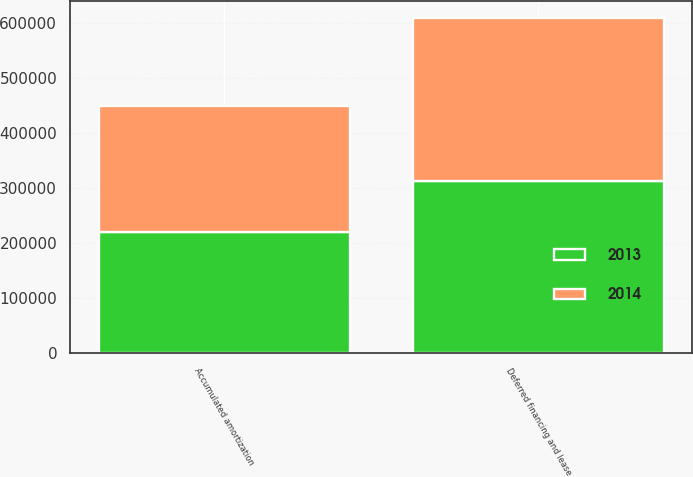Convert chart. <chart><loc_0><loc_0><loc_500><loc_500><stacked_bar_chart><ecel><fcel>Deferred financing and lease<fcel>Accumulated amortization<nl><fcel>2013<fcel>312569<fcel>220481<nl><fcel>2014<fcel>296359<fcel>229054<nl></chart> 